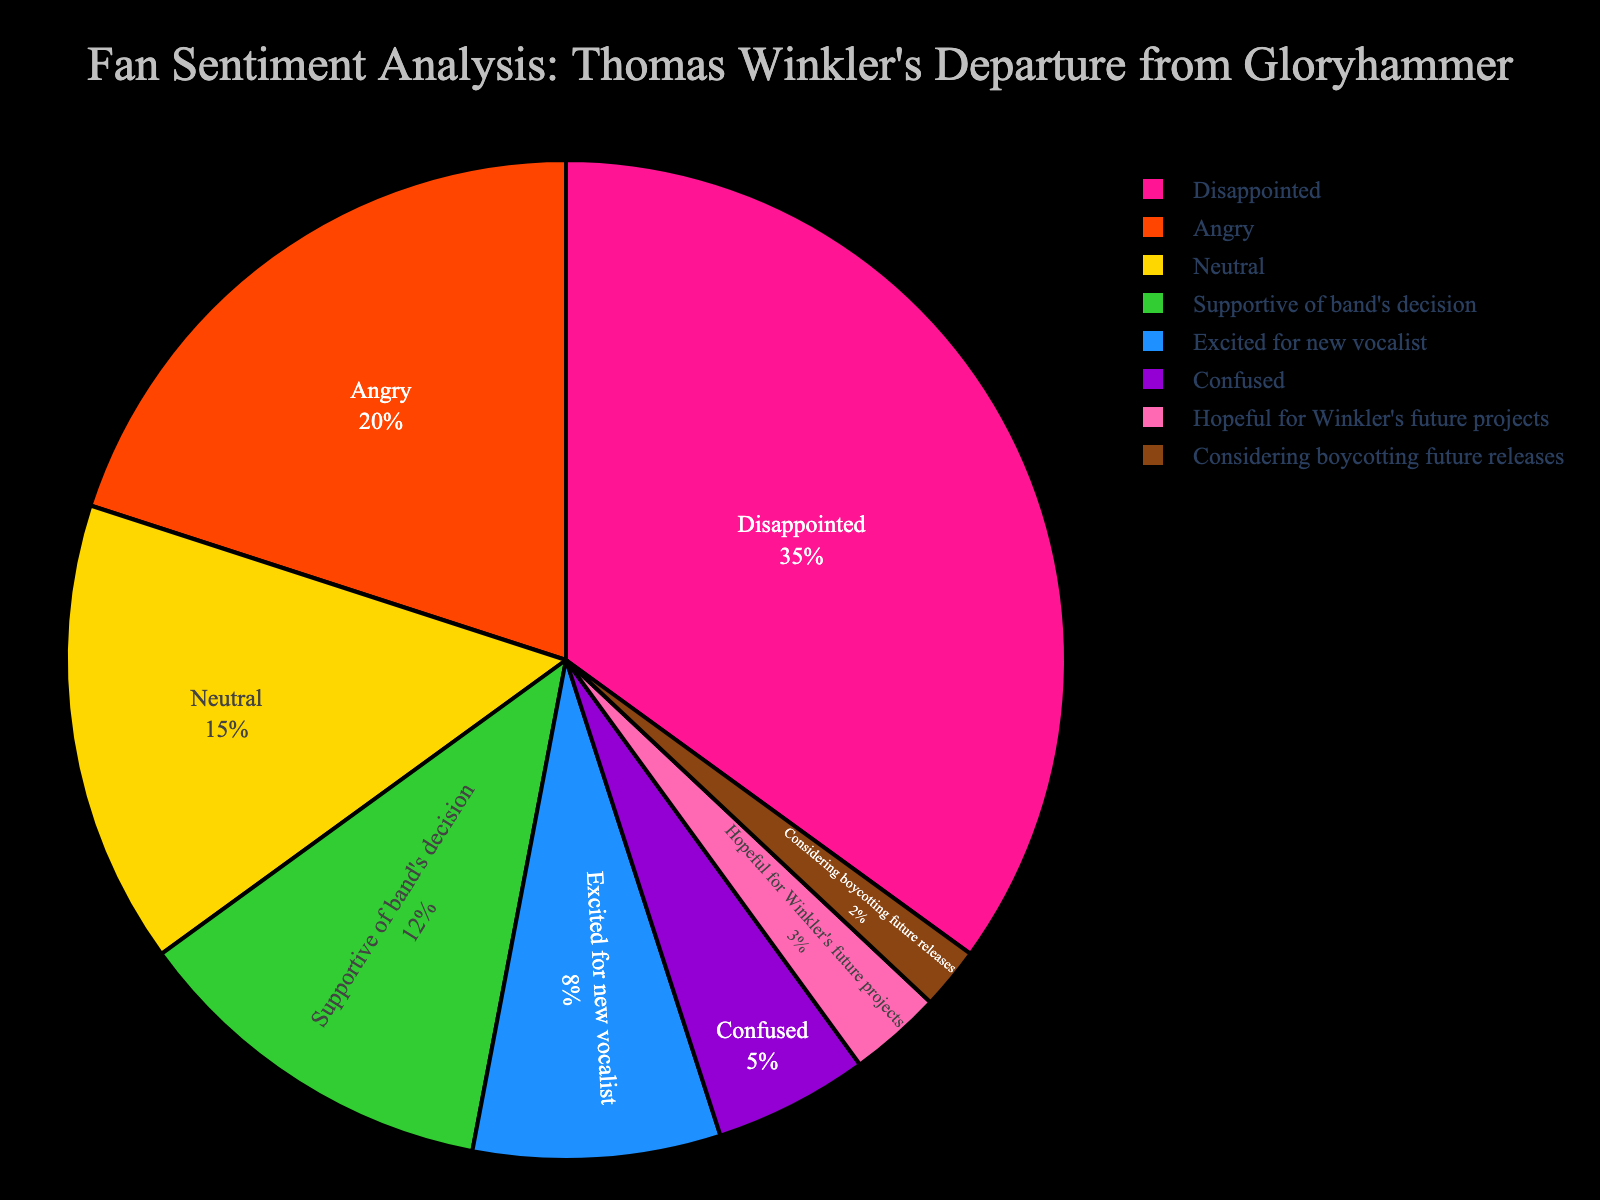What percentage of fans are disappointed about Thomas Winkler's departure? To find this, locate the segment labeled "Disappointed" in the pie chart. Its percentage is directly shown next to or inside the segment.
Answer: 35% Which sentiment is more common among fans: anger or neutrality? Compare the segments labeled "Angry" and "Neutral". The "Angry" segment has a percentage of 20%, while the "Neutral" segment has a lower percentage of 15%.
Answer: Anger What is the total percentage of fans who are either supportive of the band's decision or excited for the new vocalist? Add the percentages of the segments labeled "Supportive of band's decision" (12%) and "Excited for new vocalist" (8%). 12% + 8% = 20%.
Answer: 20% Are more fans confused or considering boycotting future releases? Compare the segments labeled "Confused" and "Considering boycotting future releases". The "Confused" segment is 5%, which is greater than the 2% for the "Considering boycotting future releases" segment.
Answer: Confused What is the combined percentage of fans feeling hopeful for Winkler's future projects and those considering boycotting future releases? Add the percentages of the segments labeled "Hopeful for Winkler's future projects" (3%) and "Considering boycotting future releases" (2%). 3% + 2% = 5%.
Answer: 5% Which sentiment has the smallest percentage of fans? Identify the smallest segment in the pie chart. The "Considering boycotting future releases" segment has the smallest percentage at 2%.
Answer: Considering boycotting future releases Which section is larger: "Excited for new vocalist" or "Neutral"? Compare the segments labeled "Excited for new vocalist" (8%) and "Neutral" (15%). The "Neutral" segment is larger at 15%.
Answer: Neutral How many more percentage points are fans disappointed than hopeful for Winkler's future projects? Subtract the percentage of the "Hopeful for Winkler's future projects" (3%) from the "Disappointed" (35%). 35% - 3% = 32%.
Answer: 32% How does the percentage of fans who are supportive of the band's decision compare to those who are angry? Compare the segments labeled "Supportive of band's decision" (12%) and "Angry" (20%). The percentage of fans who are angry is higher at 20%.
Answer: Angry is higher 